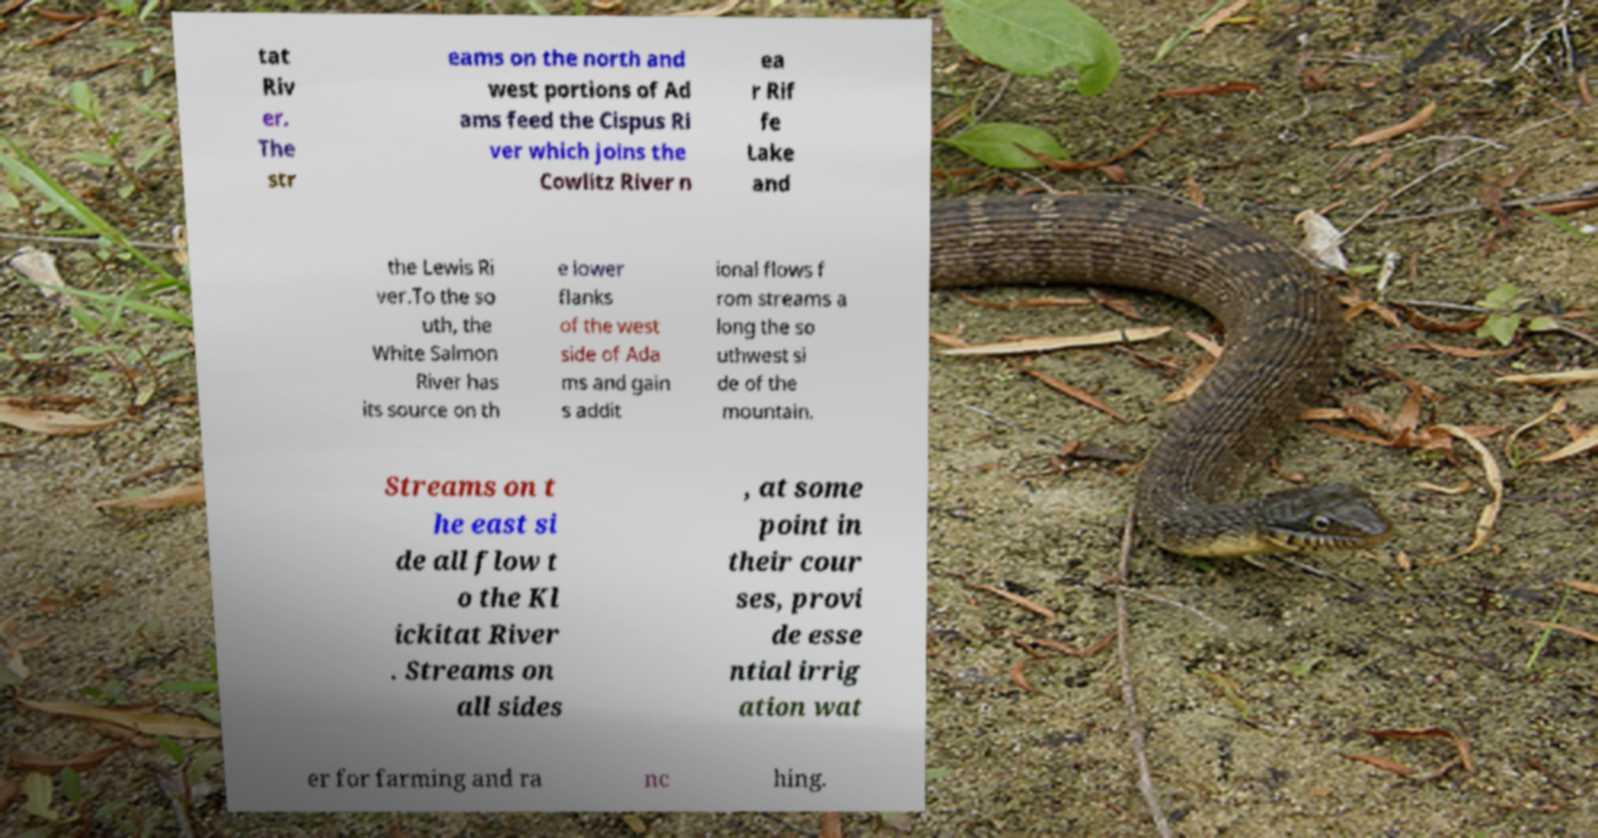What messages or text are displayed in this image? I need them in a readable, typed format. tat Riv er. The str eams on the north and west portions of Ad ams feed the Cispus Ri ver which joins the Cowlitz River n ea r Rif fe Lake and the Lewis Ri ver.To the so uth, the White Salmon River has its source on th e lower flanks of the west side of Ada ms and gain s addit ional flows f rom streams a long the so uthwest si de of the mountain. Streams on t he east si de all flow t o the Kl ickitat River . Streams on all sides , at some point in their cour ses, provi de esse ntial irrig ation wat er for farming and ra nc hing. 